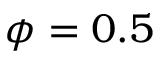Convert formula to latex. <formula><loc_0><loc_0><loc_500><loc_500>\phi = 0 . 5</formula> 